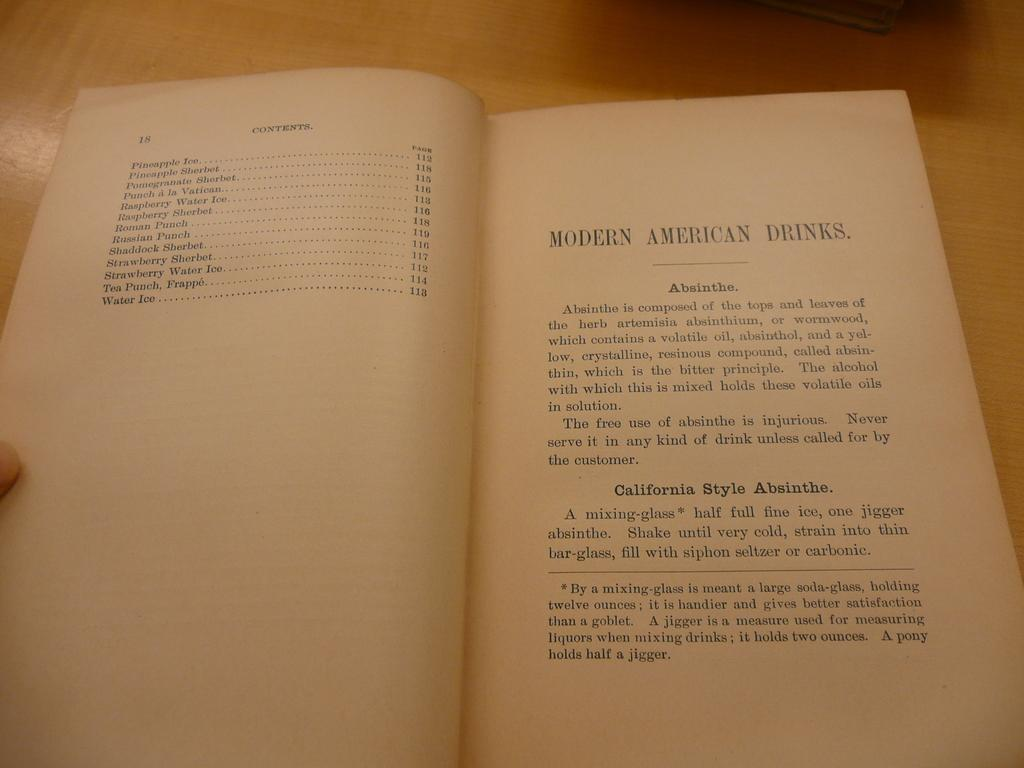Provide a one-sentence caption for the provided image. A book is open to a page about Modern American drinks. 